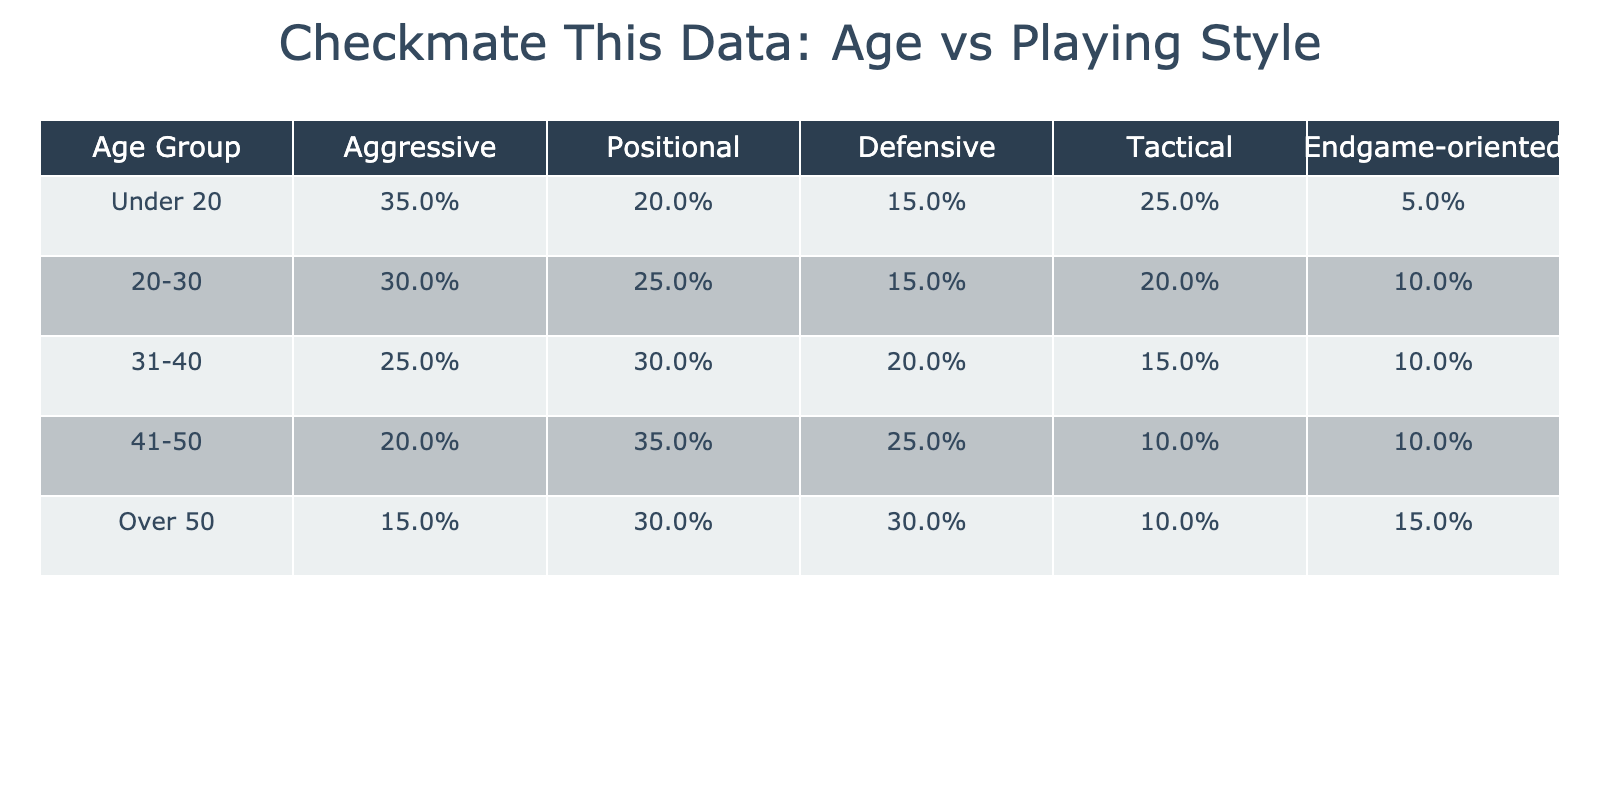What is the preferred playing style percentage for players aged 31-40? Referring to the table, the percentage of preferring each style for the age group 31-40 shows Aggressive at 25%, Positional at 30%, Defensive at 20%, Tactical at 15%, and Endgame-oriented at 10%.
Answer: Aggressive: 25%, Positional: 30%, Defensive: 20%, Tactical: 15%, Endgame-oriented: 10% Which age group has the highest percentage of aggressive players? By examining each age group, we see that the Under 20 category has the highest percentage of aggressive players at 35%.
Answer: Under 20 What is the difference in percentage of defensive players between the age groups 41-50 and Over 50? The age group 41-50 has 25% of players preferring a defensive style, while Over 50 has 30%. The difference is calculated as 30% - 25% = 5%.
Answer: 5% What is the average percentage of tactical players across all age groups? To find the average, we add the tactical percentages: 25% (Under 20) + 20% (20-30) + 15% (31-40) + 10% (41-50) + 10% (Over 50) = 90%. There are 5 age groups, so the average is 90% / 5 = 18%.
Answer: 18% Is there an age group with zero preference for endgame-oriented play? Looking at the endgame-oriented percentage for each age group, none of them have a value of 0%. Therefore, the answer is no.
Answer: No What is the relationship between age and aggressive playing style based on the table? By comparing the values, it's clear that as the age increases, the percentage of aggressive players decreases. The Under 20 group has the highest at 35%, and it decreases to 15% for those Over 50, indicating a negative correlation.
Answer: Negative correlation Which playing style remains consistently lower than 10% for the under 20 and over 50 age groups? In the table, the endgame-oriented style consistently remains below 10% for the Under 20 (5%) and the Over 50 (15%). Therefore, the consistent lower style below 10% is endgame-oriented.
Answer: Endgame-oriented 